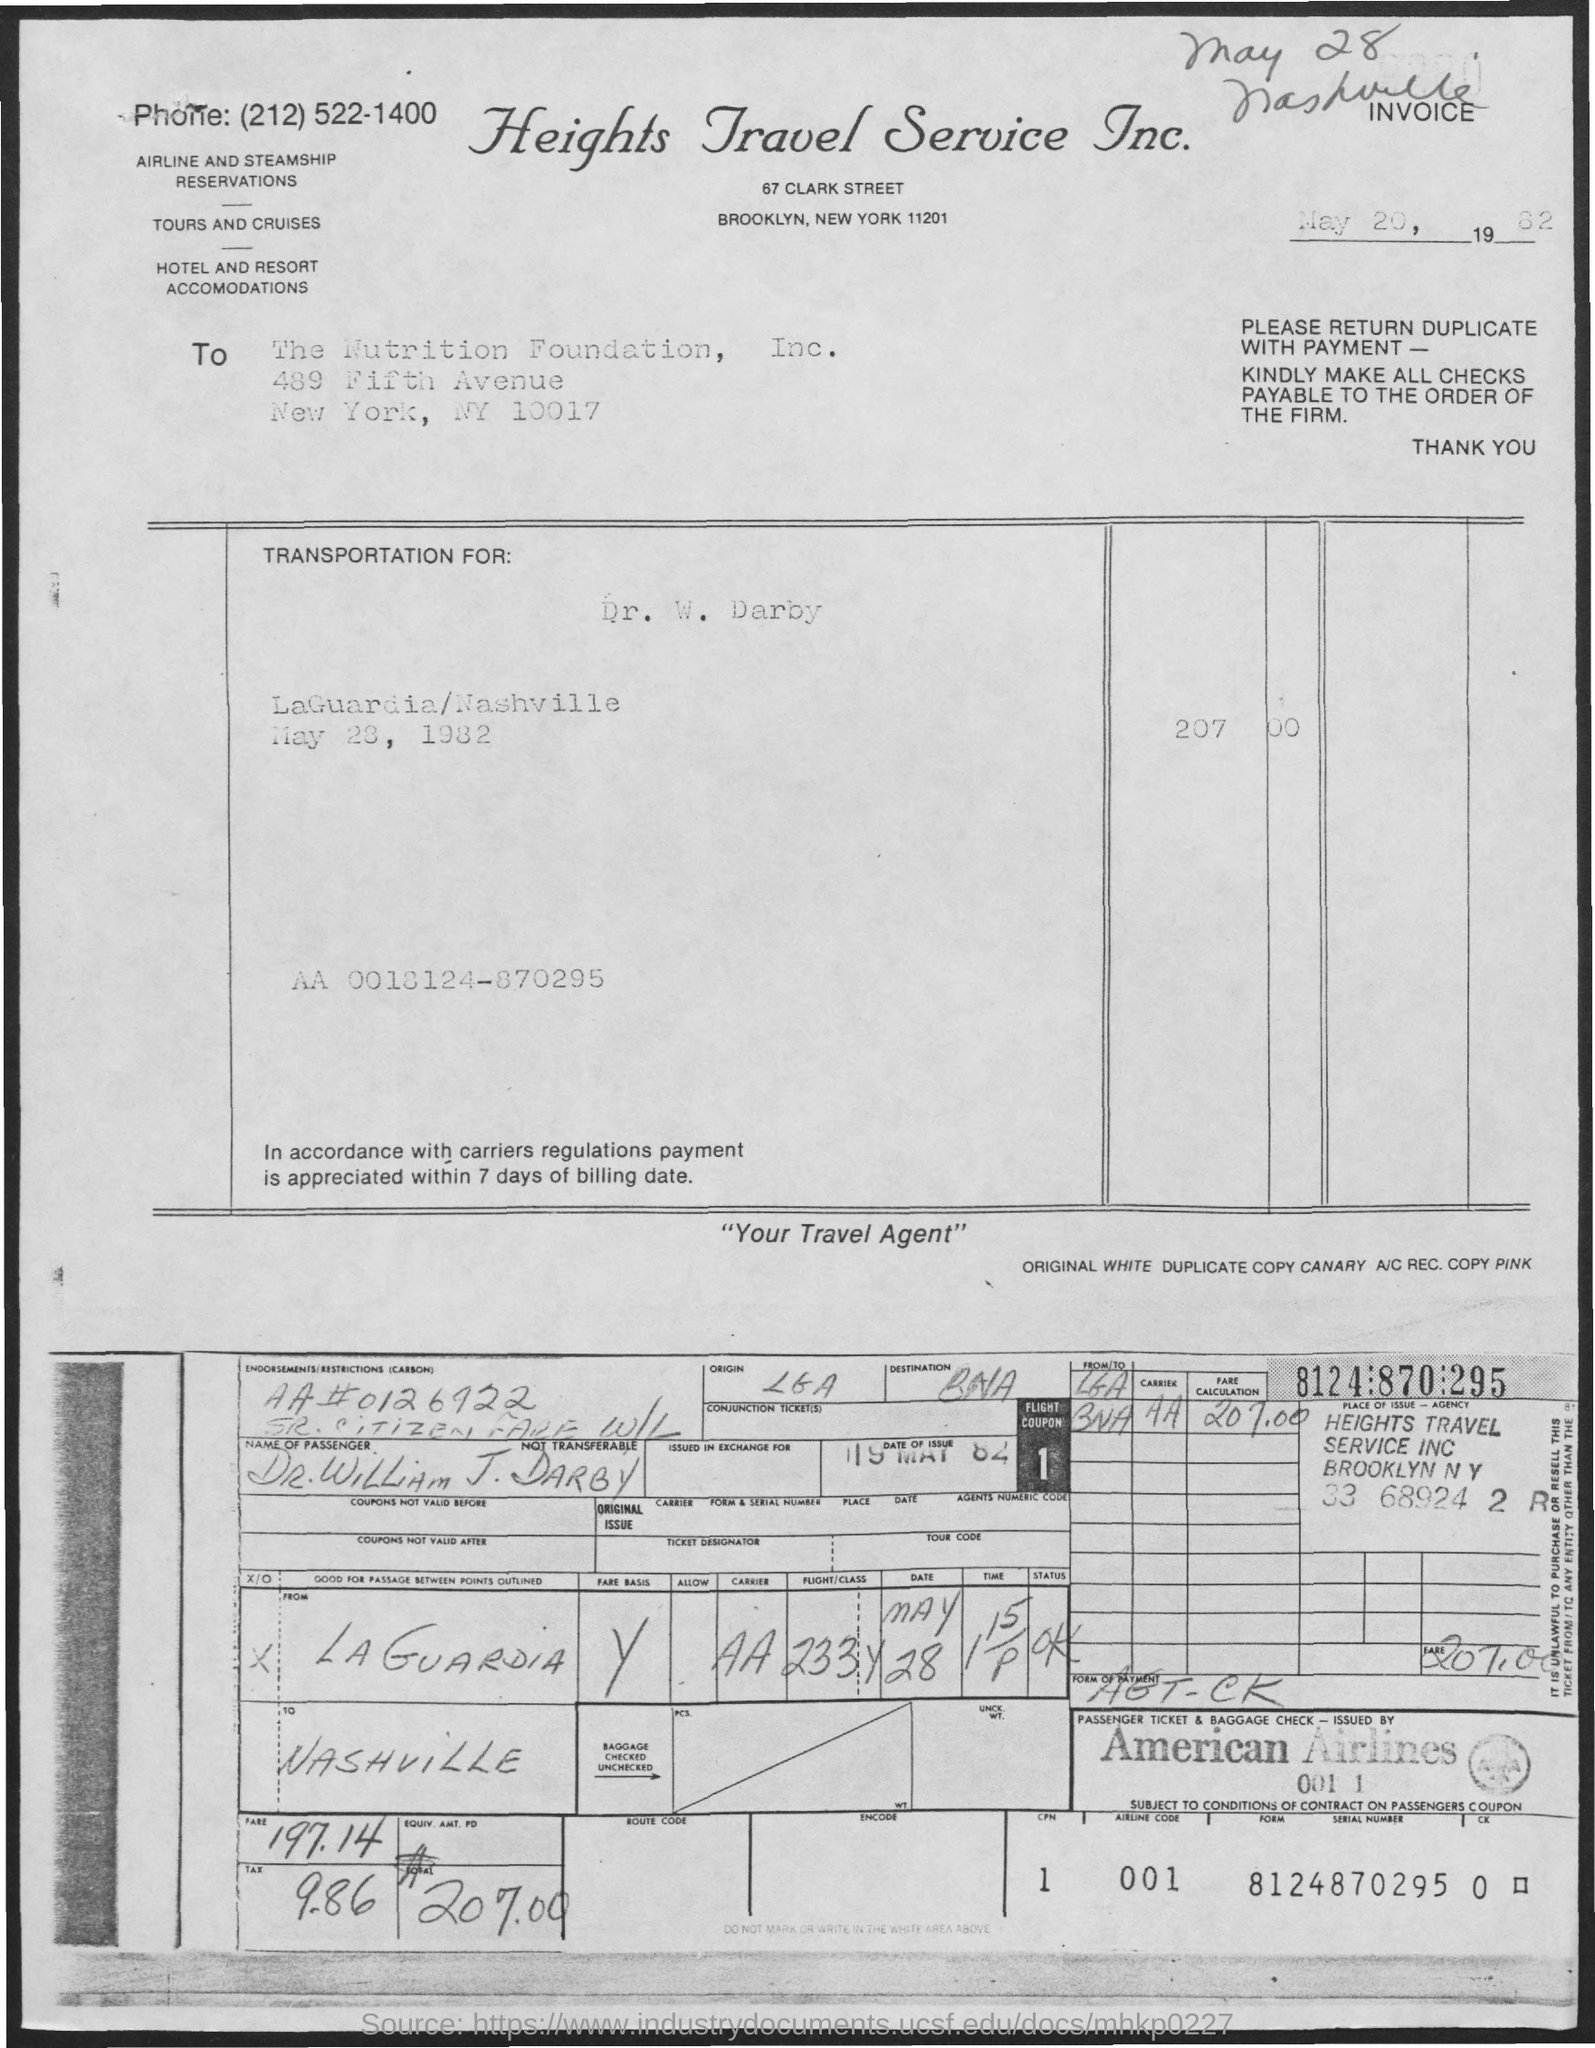What is the Flight coupon number?
Offer a very short reply. 1. What is the name of the Airline?
Provide a succinct answer. American Airlines. What is the Airline Code?
Give a very brief answer. 001. What is the serial number?
Your answer should be very brief. 8124870295. What is the title of the document?
Make the answer very short. Heights Travel Service Inc. 